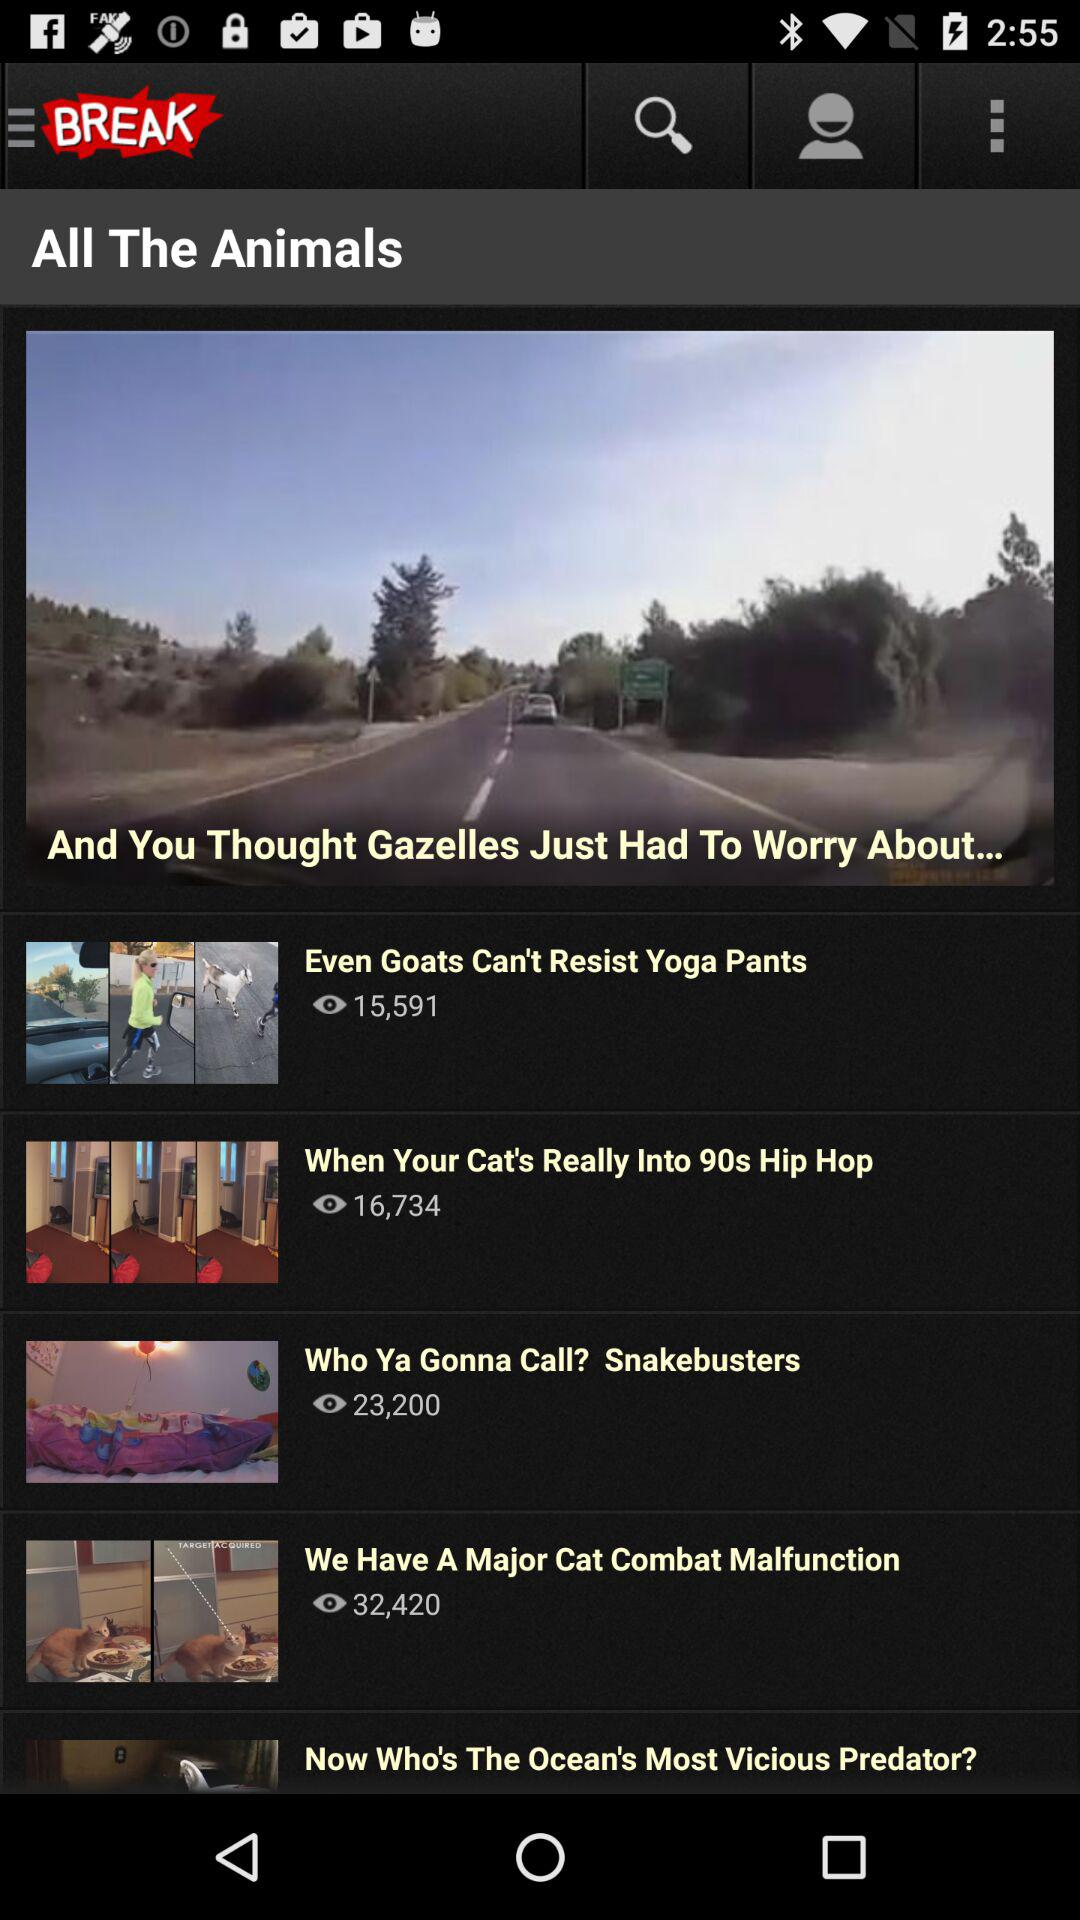How many views are there of "When Your Cat's Really Into 90s Hip Hop"? There are 16,734 views of "When Your Cat's Really Into 90s Hip Hop". 